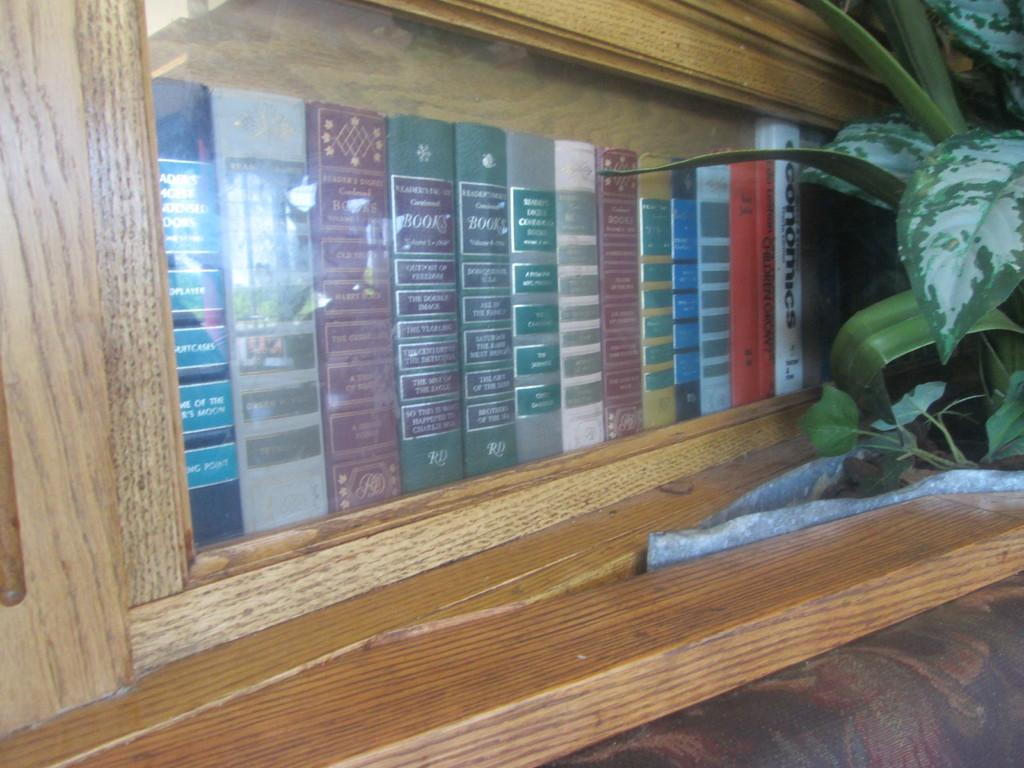What is the main object in the center of the image? There is a bookshelf in the center of the image. What is stored on the bookshelf? The bookshelf contains books. What type of vegetation is on the right side of the image? There is a plant on the right side of the image. How many bubbles are floating around the bookshelf in the image? There are no bubbles present in the image. 